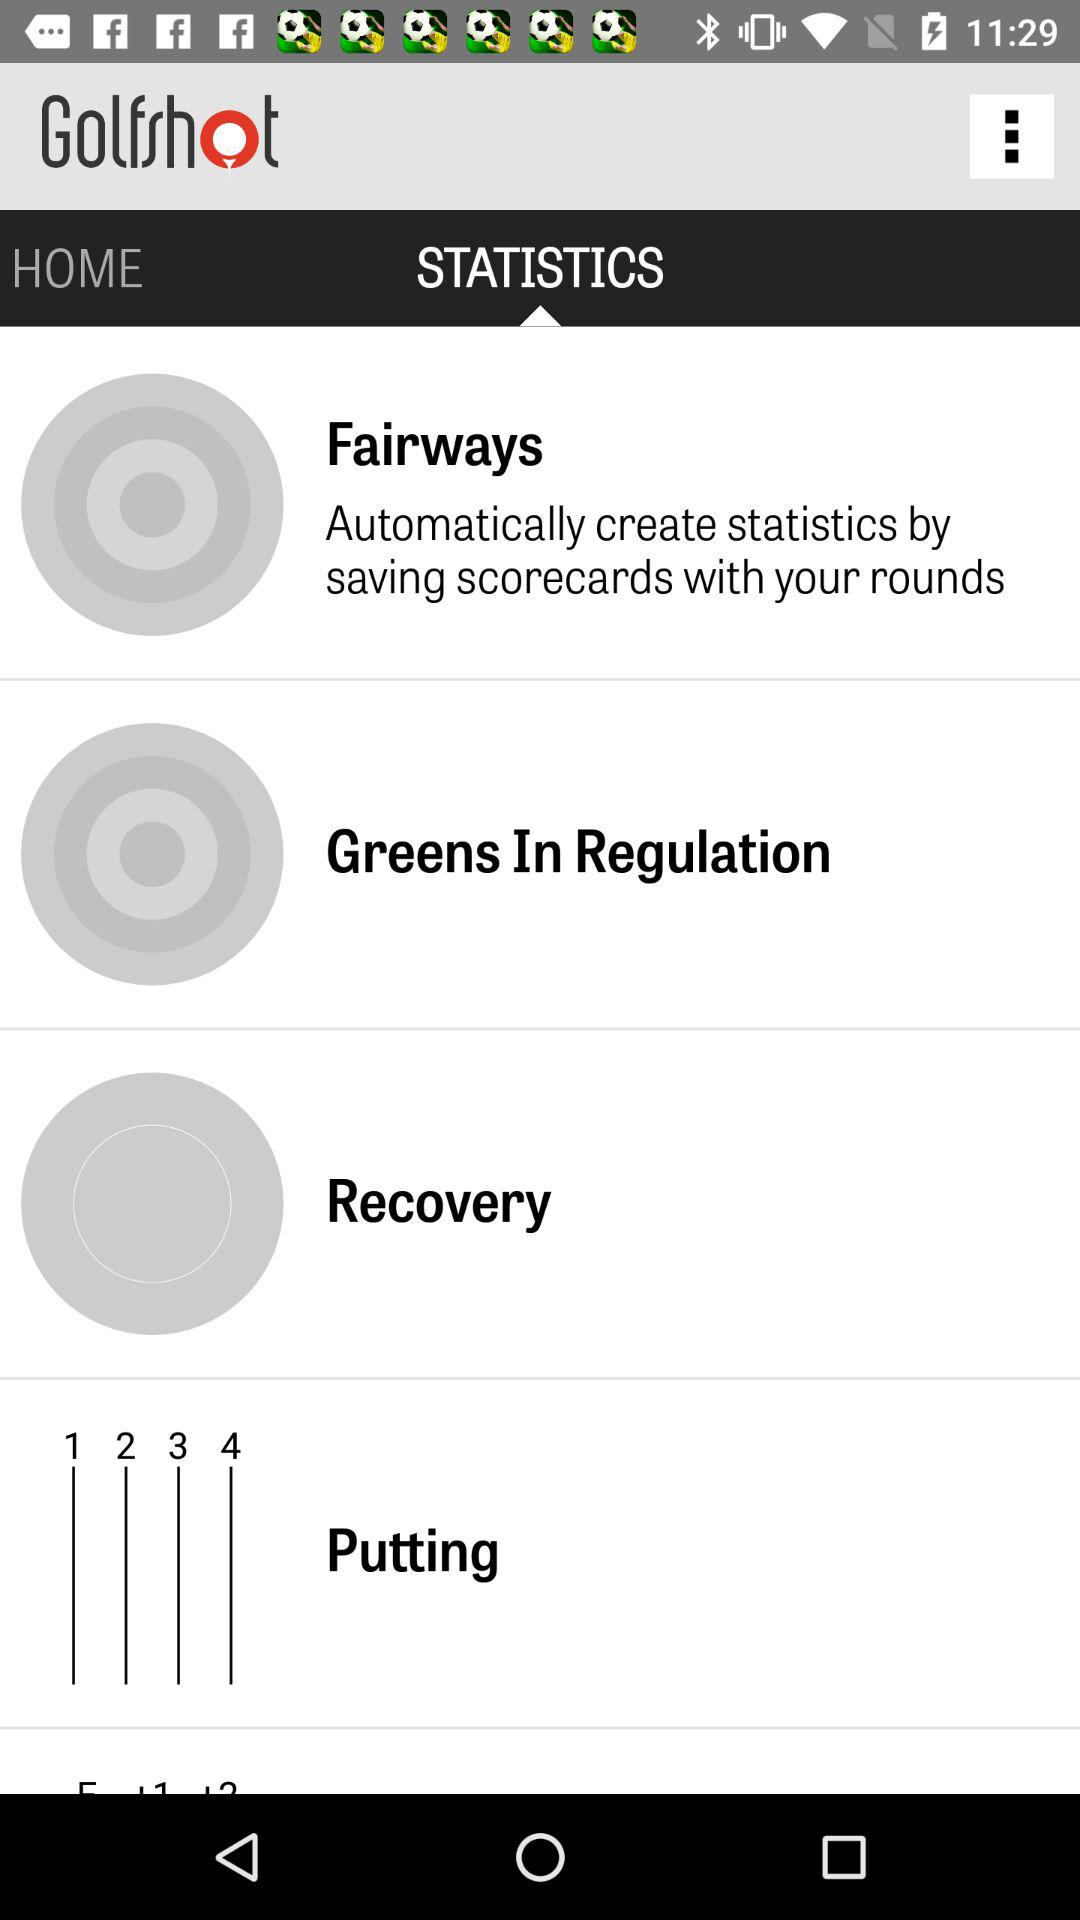What is the application name? The application name is "Golfshot". 